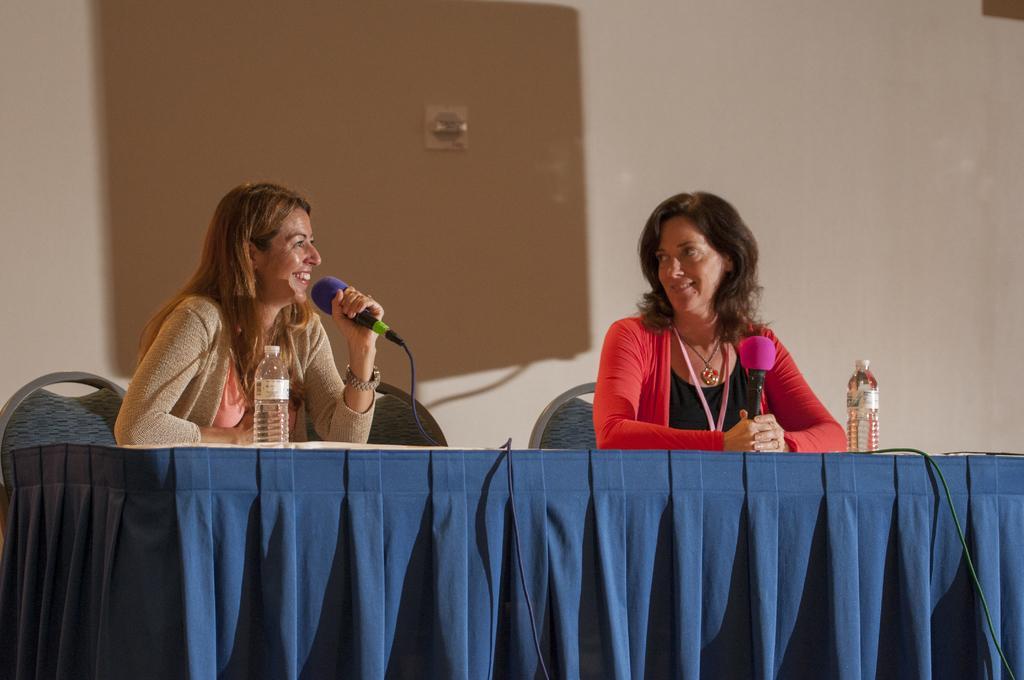In one or two sentences, can you explain what this image depicts? As we can see in the image there is a white color wall and two people sitting on chairs and in front of them there is a table. On table there are bottles. 